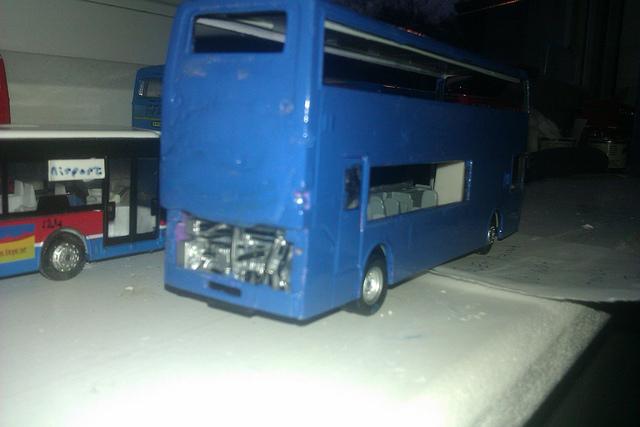Is this a double decker bus?
Give a very brief answer. Yes. Is this vehicle blue?
Answer briefly. Yes. Is there a calendar in the picture?
Be succinct. No. Is this a bus from the U.K.?
Short answer required. Yes. What color are the buses?
Write a very short answer. Blue. Is the bus full?
Quick response, please. No. Is this a toy?
Answer briefly. Yes. Is this scene nighttime?
Keep it brief. Yes. What type of vehicle is this?
Quick response, please. Bus. What color is the larger bus?
Answer briefly. Blue. Can you prepare food here?
Short answer required. No. 